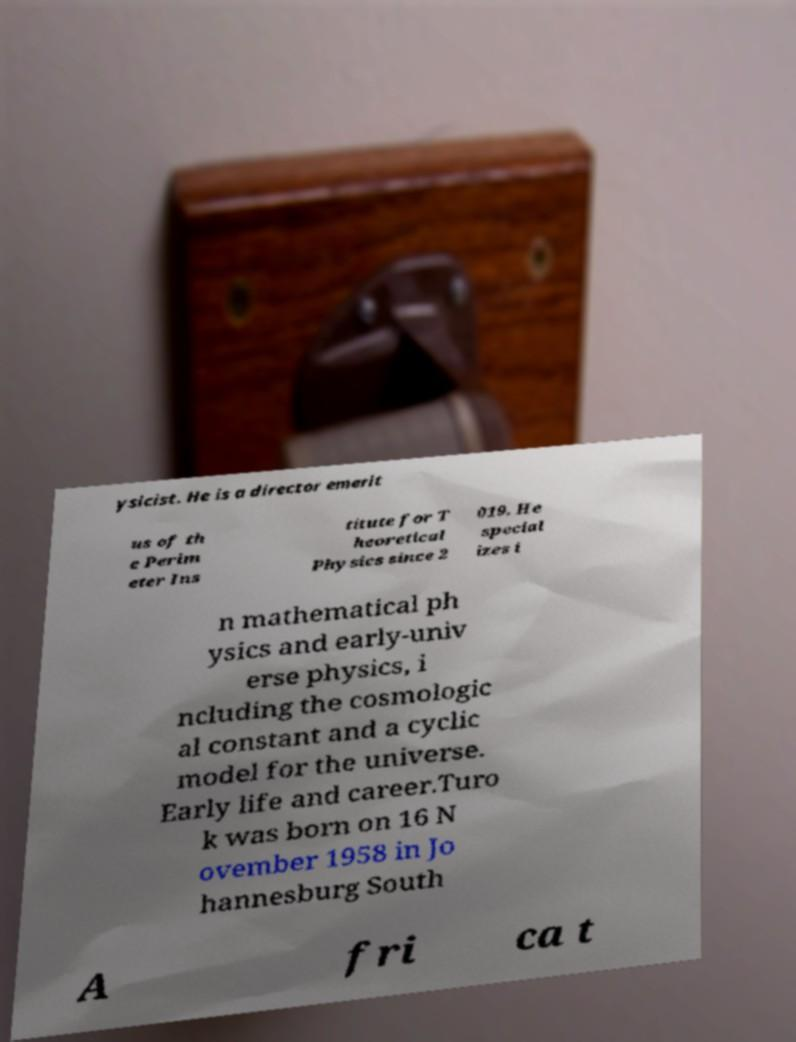Please read and relay the text visible in this image. What does it say? ysicist. He is a director emerit us of th e Perim eter Ins titute for T heoretical Physics since 2 019. He special izes i n mathematical ph ysics and early-univ erse physics, i ncluding the cosmologic al constant and a cyclic model for the universe. Early life and career.Turo k was born on 16 N ovember 1958 in Jo hannesburg South A fri ca t 